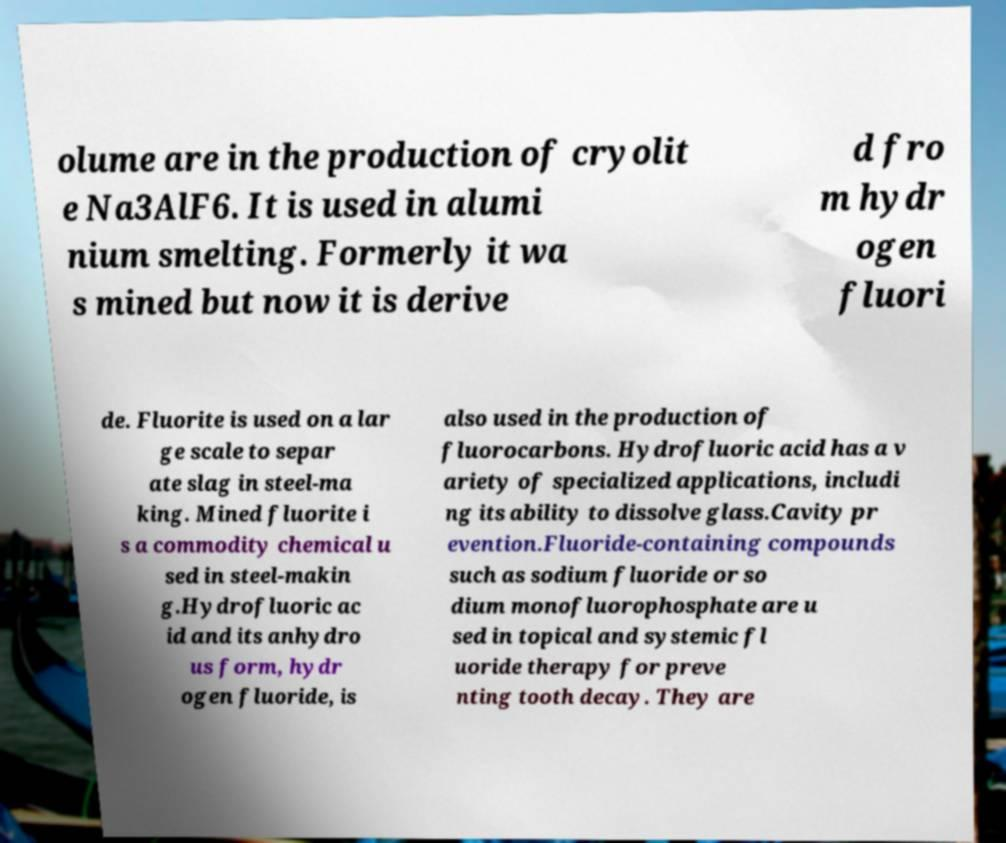Could you assist in decoding the text presented in this image and type it out clearly? olume are in the production of cryolit e Na3AlF6. It is used in alumi nium smelting. Formerly it wa s mined but now it is derive d fro m hydr ogen fluori de. Fluorite is used on a lar ge scale to separ ate slag in steel-ma king. Mined fluorite i s a commodity chemical u sed in steel-makin g.Hydrofluoric ac id and its anhydro us form, hydr ogen fluoride, is also used in the production of fluorocarbons. Hydrofluoric acid has a v ariety of specialized applications, includi ng its ability to dissolve glass.Cavity pr evention.Fluoride-containing compounds such as sodium fluoride or so dium monofluorophosphate are u sed in topical and systemic fl uoride therapy for preve nting tooth decay. They are 